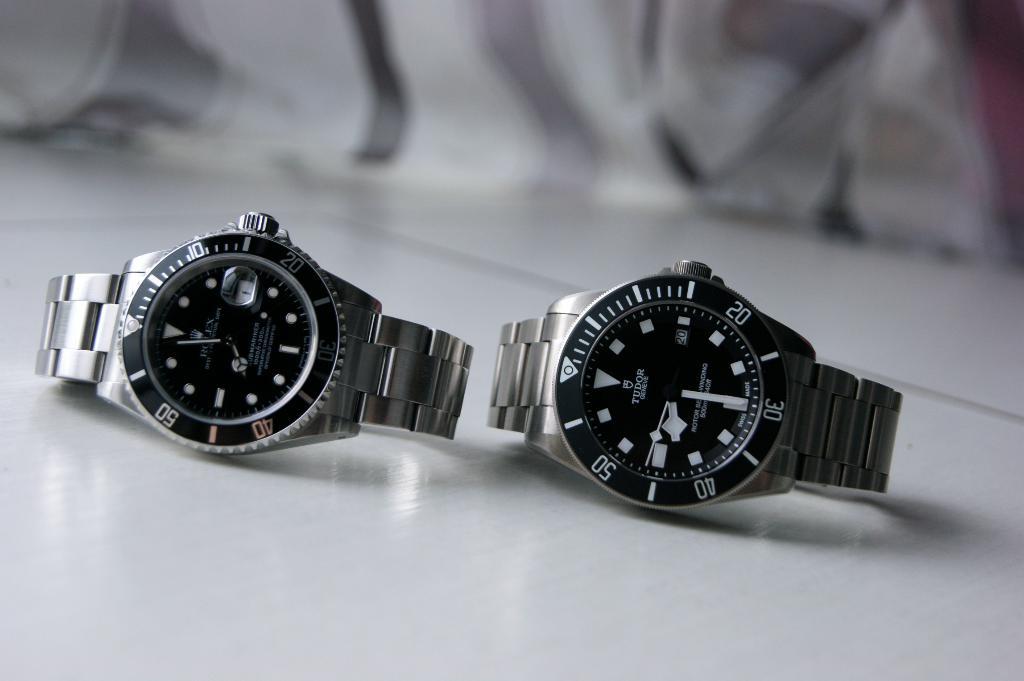Is the right watch a tudor watch?
Your response must be concise. Yes. What is the time on the watch on the right?
Offer a very short reply. 8:29. 